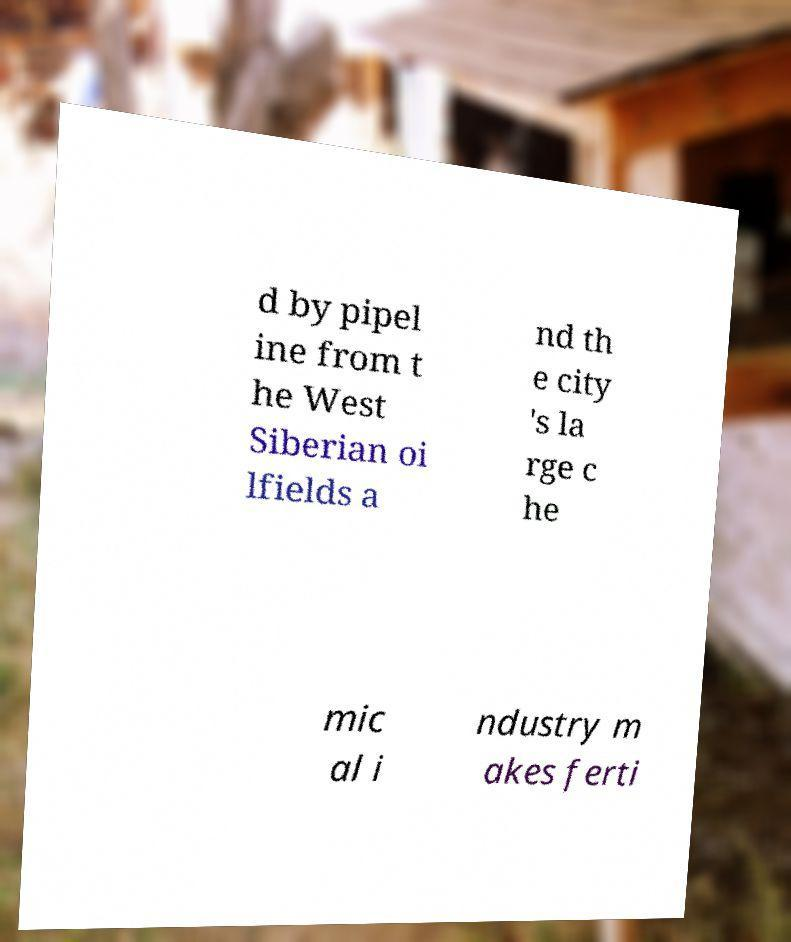There's text embedded in this image that I need extracted. Can you transcribe it verbatim? d by pipel ine from t he West Siberian oi lfields a nd th e city 's la rge c he mic al i ndustry m akes ferti 